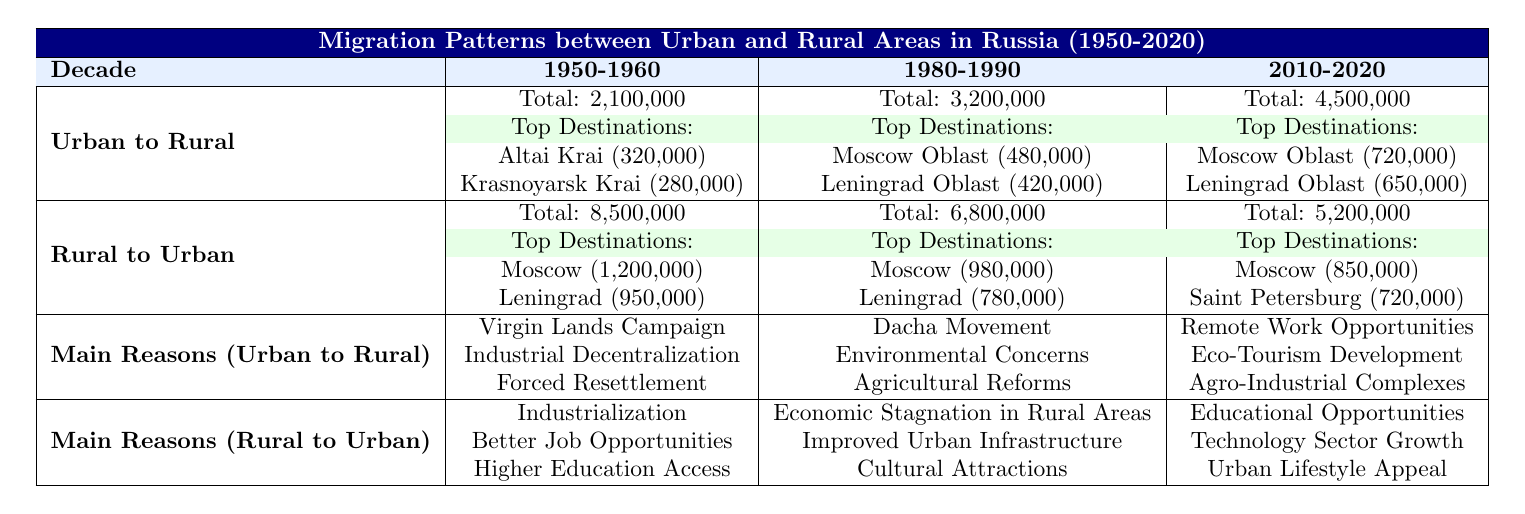What was the total number of migrants from urban to rural areas in the decade 1980-1990? The table shows that in the decade 1980-1990, the total number of migrants from urban to rural areas is listed as 3,200,000.
Answer: 3,200,000 Which region received the highest number of urban to rural migrants in the decade 1950-1960? According to the table, in the decade 1950-1960, Altai Krai received the highest number of migrants from urban to rural areas, with 320,000 migrants.
Answer: Altai Krai What was the total number of rural to urban migrants in the decade 2010-2020? The data in the table indicates that the total number of rural to urban migrants in the decade 2010-2020 is 5,200,000.
Answer: 5,200,000 In which decade did the number of rural to urban migrants peak? By analyzing the total number of rural to urban migrants across the decades, we see that 8,500,000 in 1950-1960 is the highest number, indicating it was the peak.
Answer: 1950-1960 How many more migrants moved from rural to urban areas in 1980-1990 compared to 2010-2020? The total migrants in 1980-1990 is 6,800,000, and in 2010-2020, it is 5,200,000. The difference is 6,800,000 - 5,200,000 = 1,600,000.
Answer: 1,600,000 What is the average number of rural to urban migrants for the three decades provided? The total number of rural to urban migrants across the decades is 8,500,000 + 6,800,000 + 5,200,000 = 20,500,000. There are 3 decades, therefore, the average is 20,500,000 / 3 = 6,833,333.
Answer: 6,833,333 Did more people migrate from urban to rural areas or from rural to urban areas in the decade 1950-1960? From the table, 2,100,000 migrated from urban to rural areas while 8,500,000 migrated from rural to urban areas, indicating that more migrated to urban.
Answer: Yes, more migrated from rural to urban Which region had the second highest number of urban to rural migrants in 1980-1990? The table indicates that in the 1980-1990 decade, Leningrad Oblast had the second highest number of urban to rural migrants with 420,000.
Answer: Leningrad Oblast Which city received the greatest number of rural to urban migrants in the decade 2010-2020? The table shows that Moscow received the greatest number of migrants from rural to urban areas in 2010-2020, with a total of 850,000 migrants.
Answer: Moscow What were the primary reasons for urban to rural migration in the decade 2010-2020? The primary reasons listed in the table for urban to rural migration in 2010-2020 include Remote Work Opportunities, Eco-Tourism Development, and Agro-Industrial Complexes.
Answer: Remote Work Opportunities, Eco-Tourism Development, Agro-Industrial Complexes 